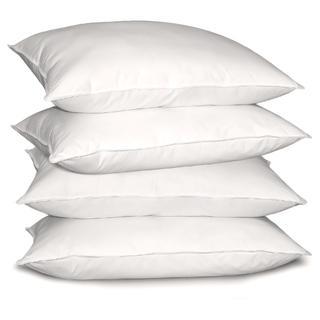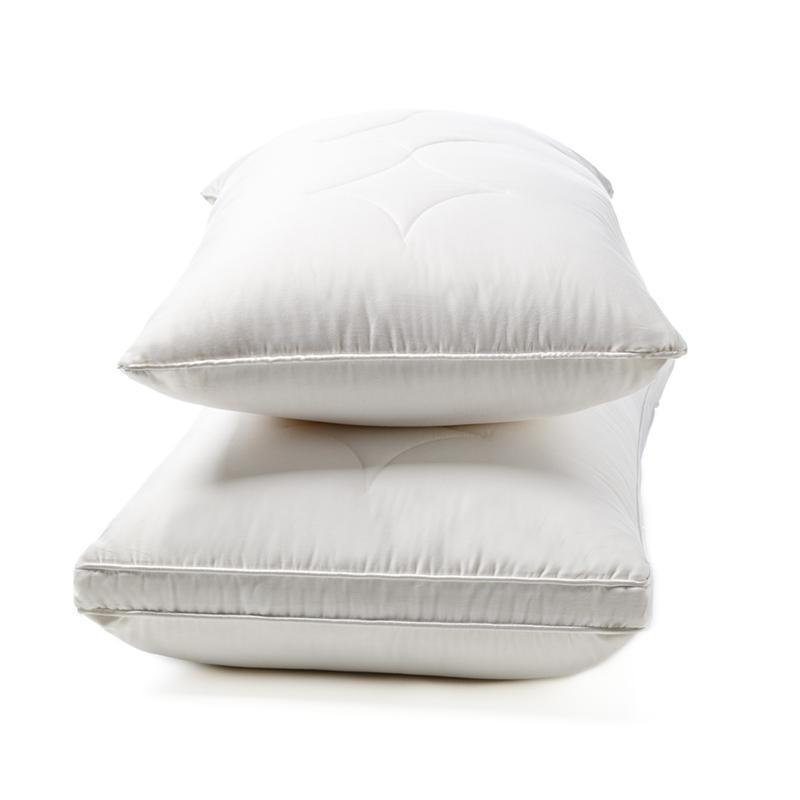The first image is the image on the left, the second image is the image on the right. For the images shown, is this caption "The left image contains a stack of four pillows and the right image contains a stack of two pillows." true? Answer yes or no. Yes. The first image is the image on the left, the second image is the image on the right. For the images displayed, is the sentence "The right image contains two  white pillows stacked vertically on top of each other." factually correct? Answer yes or no. Yes. 